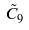Convert formula to latex. <formula><loc_0><loc_0><loc_500><loc_500>\tilde { C } _ { 9 }</formula> 